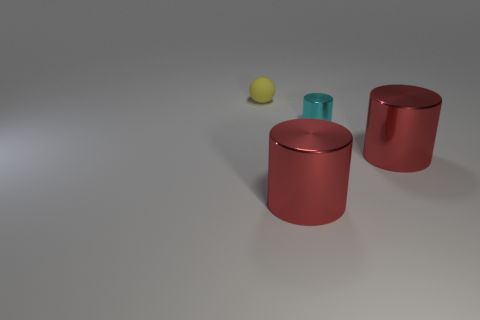Subtract 1 cylinders. How many cylinders are left? 2 Subtract all red shiny cylinders. How many cylinders are left? 1 Add 4 cyan shiny objects. How many objects exist? 8 Subtract all cylinders. How many objects are left? 1 Subtract 0 green cubes. How many objects are left? 4 Subtract all big cyan spheres. Subtract all small yellow matte things. How many objects are left? 3 Add 4 yellow rubber objects. How many yellow rubber objects are left? 5 Add 2 small objects. How many small objects exist? 4 